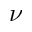Convert formula to latex. <formula><loc_0><loc_0><loc_500><loc_500>\nu</formula> 